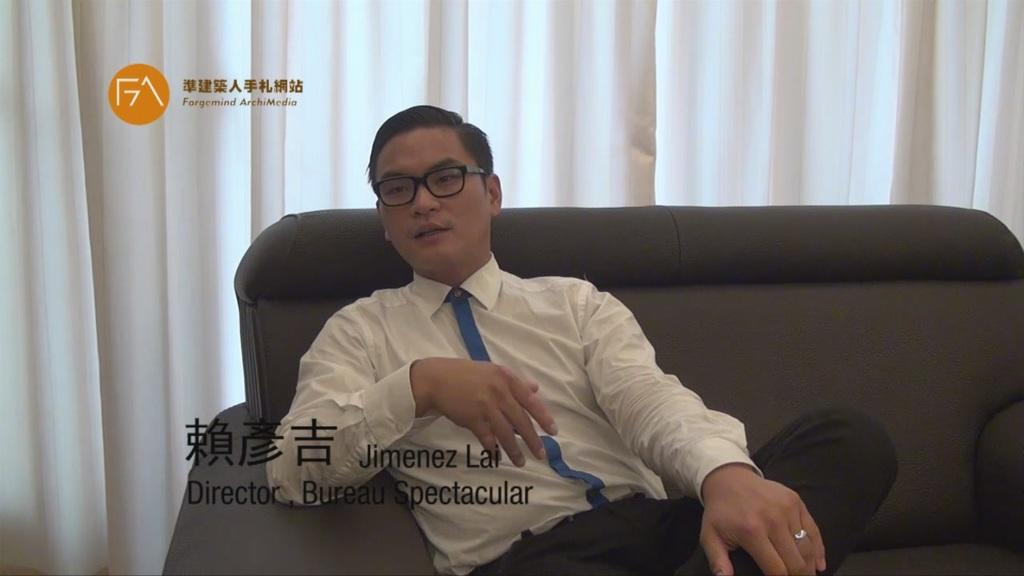What is the man in the image doing? The man is sitting on a sofa in the image. Can you describe any other elements in the image? Yes, there is a curtain in the image. What type of agreement is being discussed by the man and the curtain in the image? There is no indication in the image that the man and the curtain are discussing any agreement. 